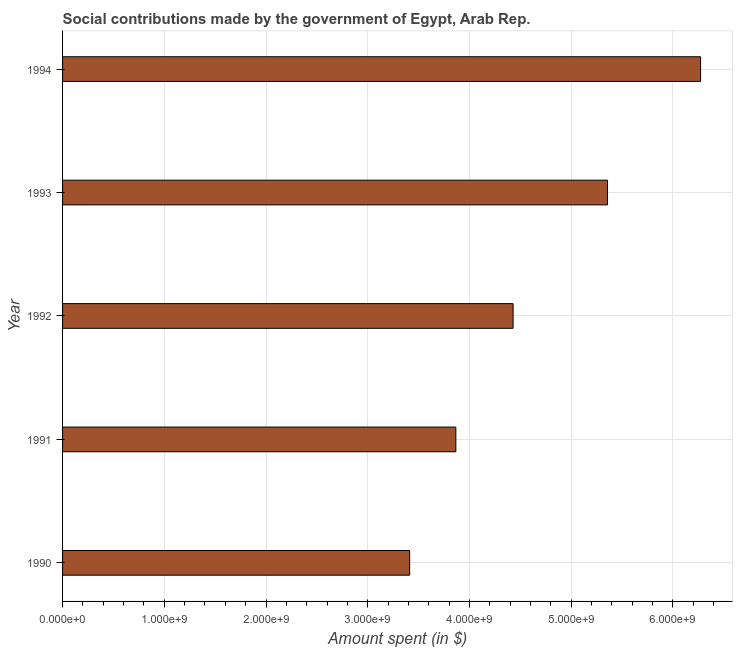What is the title of the graph?
Offer a terse response. Social contributions made by the government of Egypt, Arab Rep. What is the label or title of the X-axis?
Make the answer very short. Amount spent (in $). What is the amount spent in making social contributions in 1994?
Your answer should be very brief. 6.27e+09. Across all years, what is the maximum amount spent in making social contributions?
Offer a terse response. 6.27e+09. Across all years, what is the minimum amount spent in making social contributions?
Keep it short and to the point. 3.41e+09. What is the sum of the amount spent in making social contributions?
Make the answer very short. 2.33e+1. What is the difference between the amount spent in making social contributions in 1993 and 1994?
Offer a very short reply. -9.15e+08. What is the average amount spent in making social contributions per year?
Provide a short and direct response. 4.67e+09. What is the median amount spent in making social contributions?
Give a very brief answer. 4.43e+09. In how many years, is the amount spent in making social contributions greater than 2600000000 $?
Your answer should be compact. 5. Do a majority of the years between 1992 and 1994 (inclusive) have amount spent in making social contributions greater than 3200000000 $?
Make the answer very short. Yes. What is the ratio of the amount spent in making social contributions in 1991 to that in 1992?
Provide a short and direct response. 0.87. Is the amount spent in making social contributions in 1991 less than that in 1994?
Your answer should be compact. Yes. Is the difference between the amount spent in making social contributions in 1991 and 1994 greater than the difference between any two years?
Provide a short and direct response. No. What is the difference between the highest and the second highest amount spent in making social contributions?
Offer a very short reply. 9.15e+08. What is the difference between the highest and the lowest amount spent in making social contributions?
Your answer should be compact. 2.86e+09. In how many years, is the amount spent in making social contributions greater than the average amount spent in making social contributions taken over all years?
Provide a short and direct response. 2. How many bars are there?
Offer a very short reply. 5. Are all the bars in the graph horizontal?
Ensure brevity in your answer.  Yes. How many years are there in the graph?
Give a very brief answer. 5. What is the Amount spent (in $) of 1990?
Keep it short and to the point. 3.41e+09. What is the Amount spent (in $) in 1991?
Ensure brevity in your answer.  3.87e+09. What is the Amount spent (in $) in 1992?
Your response must be concise. 4.43e+09. What is the Amount spent (in $) in 1993?
Your response must be concise. 5.36e+09. What is the Amount spent (in $) of 1994?
Offer a terse response. 6.27e+09. What is the difference between the Amount spent (in $) in 1990 and 1991?
Offer a very short reply. -4.54e+08. What is the difference between the Amount spent (in $) in 1990 and 1992?
Provide a succinct answer. -1.02e+09. What is the difference between the Amount spent (in $) in 1990 and 1993?
Your answer should be very brief. -1.94e+09. What is the difference between the Amount spent (in $) in 1990 and 1994?
Your response must be concise. -2.86e+09. What is the difference between the Amount spent (in $) in 1991 and 1992?
Provide a short and direct response. -5.63e+08. What is the difference between the Amount spent (in $) in 1991 and 1993?
Your response must be concise. -1.49e+09. What is the difference between the Amount spent (in $) in 1991 and 1994?
Provide a short and direct response. -2.41e+09. What is the difference between the Amount spent (in $) in 1992 and 1993?
Give a very brief answer. -9.28e+08. What is the difference between the Amount spent (in $) in 1992 and 1994?
Your answer should be very brief. -1.84e+09. What is the difference between the Amount spent (in $) in 1993 and 1994?
Offer a terse response. -9.15e+08. What is the ratio of the Amount spent (in $) in 1990 to that in 1991?
Your answer should be compact. 0.88. What is the ratio of the Amount spent (in $) in 1990 to that in 1992?
Give a very brief answer. 0.77. What is the ratio of the Amount spent (in $) in 1990 to that in 1993?
Your answer should be compact. 0.64. What is the ratio of the Amount spent (in $) in 1990 to that in 1994?
Make the answer very short. 0.54. What is the ratio of the Amount spent (in $) in 1991 to that in 1992?
Ensure brevity in your answer.  0.87. What is the ratio of the Amount spent (in $) in 1991 to that in 1993?
Keep it short and to the point. 0.72. What is the ratio of the Amount spent (in $) in 1991 to that in 1994?
Provide a succinct answer. 0.62. What is the ratio of the Amount spent (in $) in 1992 to that in 1993?
Offer a terse response. 0.83. What is the ratio of the Amount spent (in $) in 1992 to that in 1994?
Offer a very short reply. 0.71. What is the ratio of the Amount spent (in $) in 1993 to that in 1994?
Your answer should be compact. 0.85. 